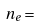Convert formula to latex. <formula><loc_0><loc_0><loc_500><loc_500>n _ { e } =</formula> 